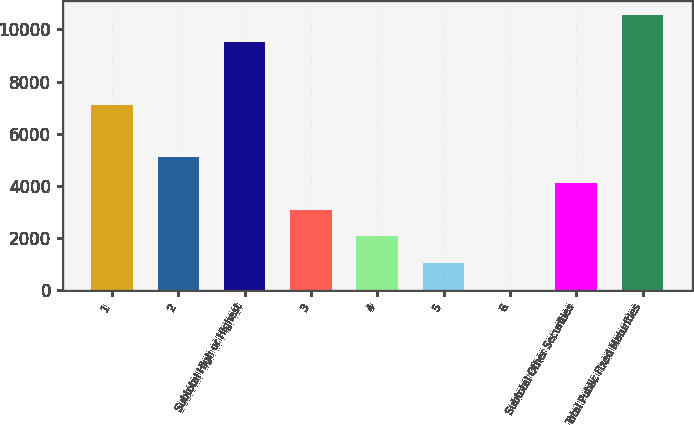Convert chart. <chart><loc_0><loc_0><loc_500><loc_500><bar_chart><fcel>1<fcel>2<fcel>Subtotal High or Highest<fcel>3<fcel>4<fcel>5<fcel>6<fcel>Subtotal Other Securities<fcel>Total Public Fixed Maturities<nl><fcel>7088<fcel>5128.5<fcel>9525<fcel>3087.9<fcel>2067.6<fcel>1047.3<fcel>27<fcel>4108.2<fcel>10545.3<nl></chart> 